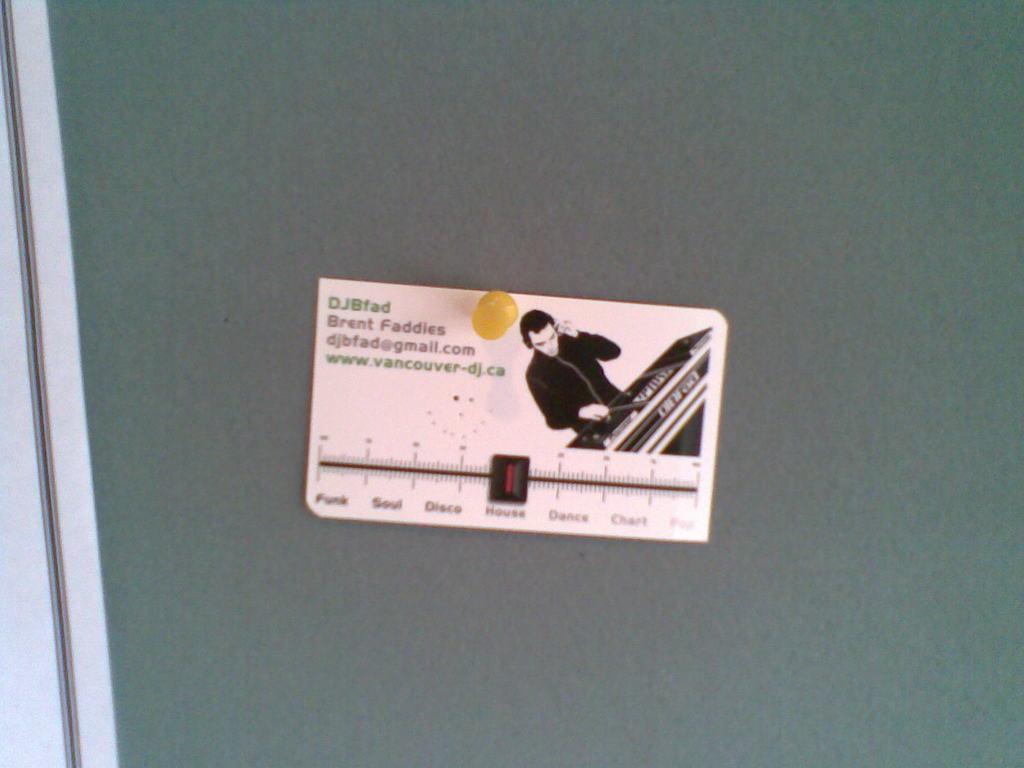Please provide a concise description of this image. In this image there is a green color boards truncated, there is an object pinned to the board. 